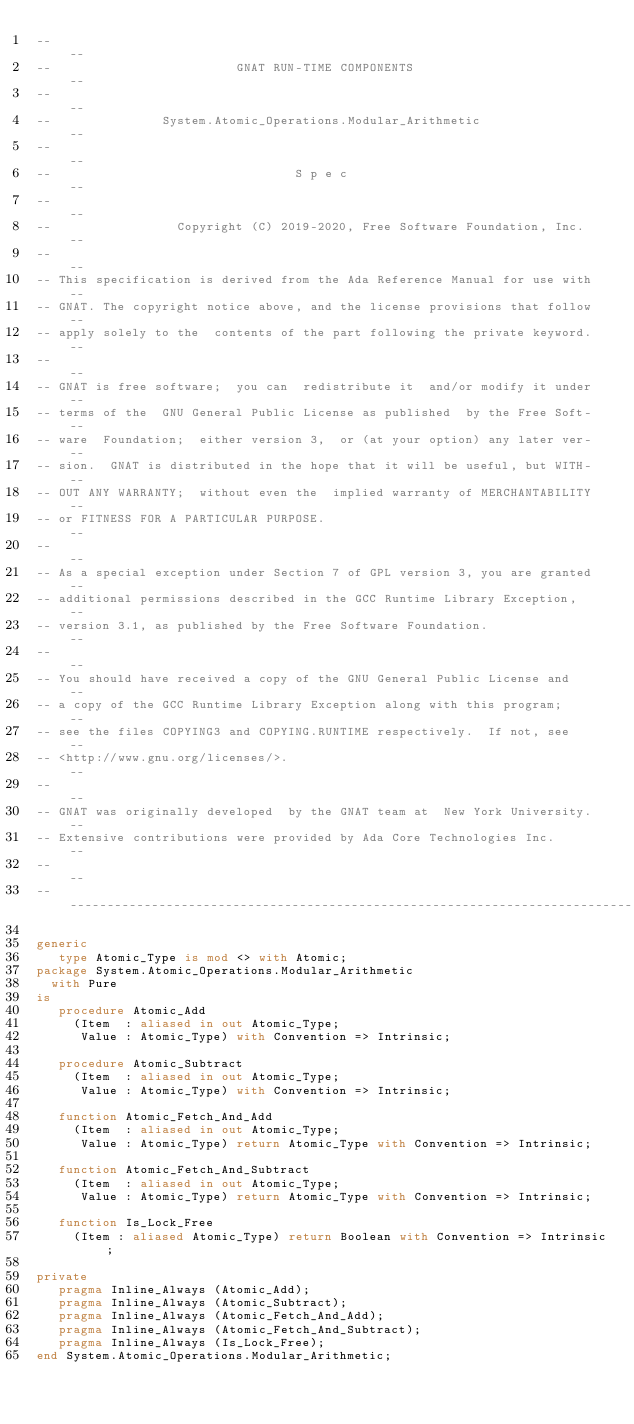Convert code to text. <code><loc_0><loc_0><loc_500><loc_500><_Ada_>--                                                                          --
--                         GNAT RUN-TIME COMPONENTS                         --
--                                                                          --
--               System.Atomic_Operations.Modular_Arithmetic                --
--                                                                          --
--                                 S p e c                                  --
--                                                                          --
--                 Copyright (C) 2019-2020, Free Software Foundation, Inc.  --
--                                                                          --
-- This specification is derived from the Ada Reference Manual for use with --
-- GNAT. The copyright notice above, and the license provisions that follow --
-- apply solely to the  contents of the part following the private keyword. --
--                                                                          --
-- GNAT is free software;  you can  redistribute it  and/or modify it under --
-- terms of the  GNU General Public License as published  by the Free Soft- --
-- ware  Foundation;  either version 3,  or (at your option) any later ver- --
-- sion.  GNAT is distributed in the hope that it will be useful, but WITH- --
-- OUT ANY WARRANTY;  without even the  implied warranty of MERCHANTABILITY --
-- or FITNESS FOR A PARTICULAR PURPOSE.                                     --
--                                                                          --
-- As a special exception under Section 7 of GPL version 3, you are granted --
-- additional permissions described in the GCC Runtime Library Exception,   --
-- version 3.1, as published by the Free Software Foundation.               --
--                                                                          --
-- You should have received a copy of the GNU General Public License and    --
-- a copy of the GCC Runtime Library Exception along with this program;     --
-- see the files COPYING3 and COPYING.RUNTIME respectively.  If not, see    --
-- <http://www.gnu.org/licenses/>.                                          --
--                                                                          --
-- GNAT was originally developed  by the GNAT team at  New York University. --
-- Extensive contributions were provided by Ada Core Technologies Inc.      --
--                                                                          --
------------------------------------------------------------------------------

generic
   type Atomic_Type is mod <> with Atomic;
package System.Atomic_Operations.Modular_Arithmetic
  with Pure
is
   procedure Atomic_Add
     (Item  : aliased in out Atomic_Type;
      Value : Atomic_Type) with Convention => Intrinsic;

   procedure Atomic_Subtract
     (Item  : aliased in out Atomic_Type;
      Value : Atomic_Type) with Convention => Intrinsic;

   function Atomic_Fetch_And_Add
     (Item  : aliased in out Atomic_Type;
      Value : Atomic_Type) return Atomic_Type with Convention => Intrinsic;

   function Atomic_Fetch_And_Subtract
     (Item  : aliased in out Atomic_Type;
      Value : Atomic_Type) return Atomic_Type with Convention => Intrinsic;

   function Is_Lock_Free
     (Item : aliased Atomic_Type) return Boolean with Convention => Intrinsic;

private
   pragma Inline_Always (Atomic_Add);
   pragma Inline_Always (Atomic_Subtract);
   pragma Inline_Always (Atomic_Fetch_And_Add);
   pragma Inline_Always (Atomic_Fetch_And_Subtract);
   pragma Inline_Always (Is_Lock_Free);
end System.Atomic_Operations.Modular_Arithmetic;
</code> 